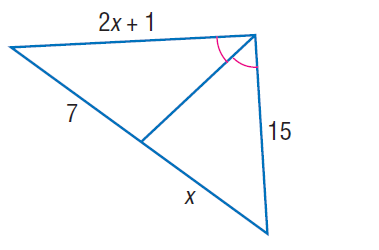Question: Find x.
Choices:
A. 7
B. 9
C. 11
D. 15
Answer with the letter. Answer: A 